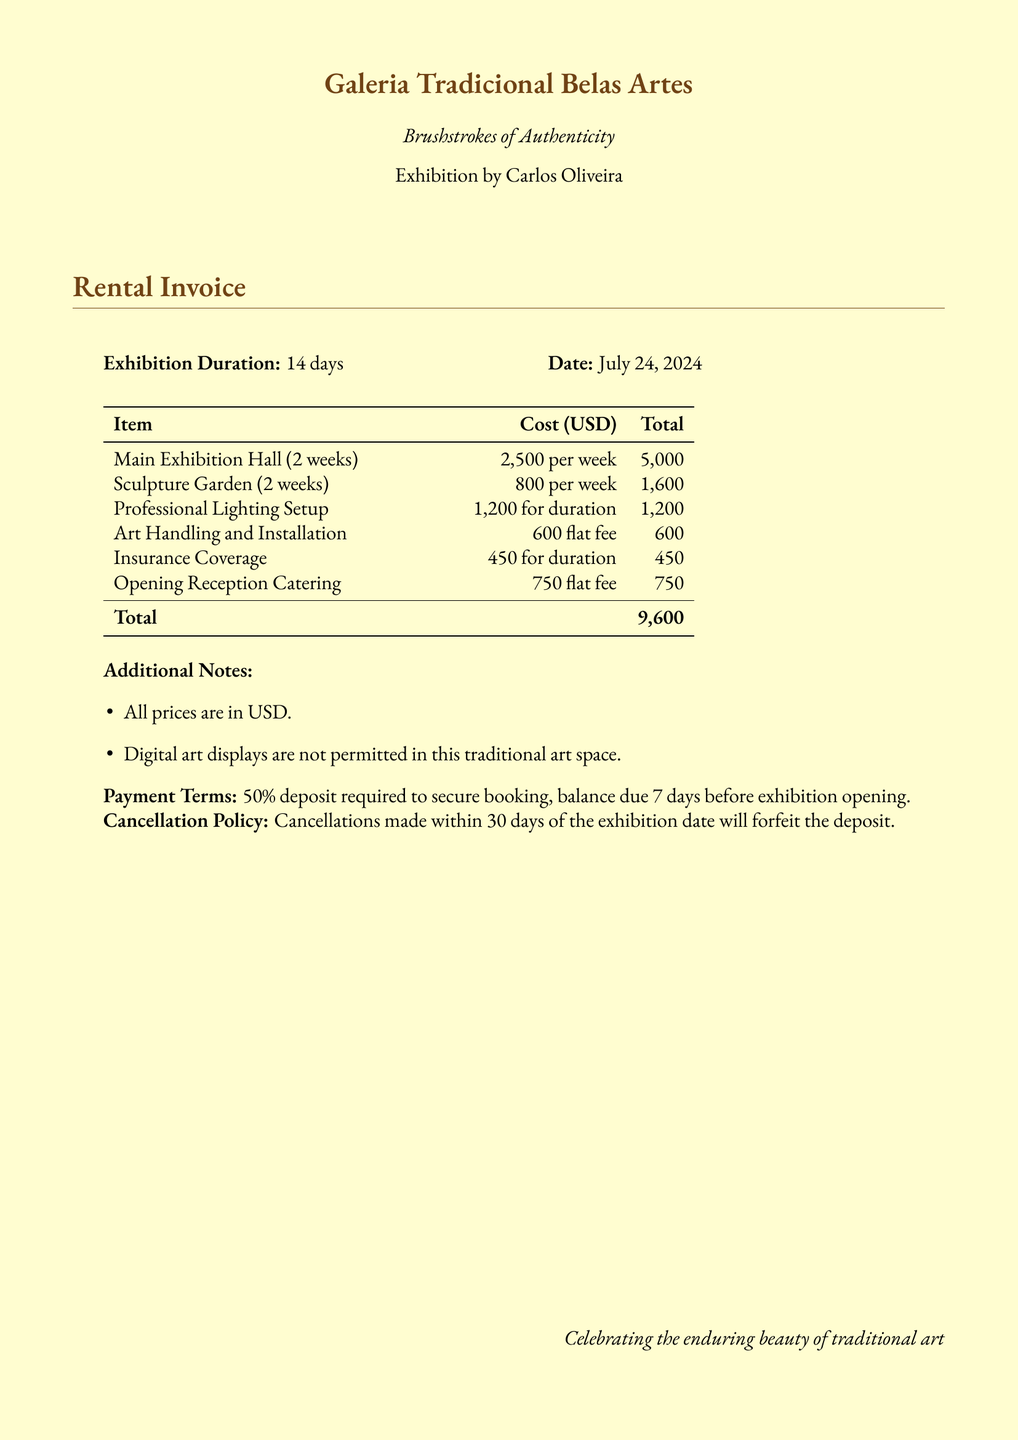What is the name of the exhibition? The exhibition is titled "Brushstrokes of Authenticity" by Carlos Oliveira.
Answer: Brushstrokes of Authenticity How long is the exhibition duration? The exhibition is set for a duration of 14 days.
Answer: 14 days What is the total cost of the gallery rental? The total cost is found at the bottom of the invoice, summing up all charges listed.
Answer: 9,600 How much is the insurance coverage? The insurance coverage cost is specified in the itemized list of costs.
Answer: 450 What is the deposit percentage required to secure booking? The payment terms specify the deposit percentage required for booking.
Answer: 50% What is included in the additional notes? The additional notes detail the price currency and restrictions on art displays.
Answer: Digital art displays are not permitted in this traditional art space What is the cancellation policy? The cancellation policy outlines the terms under which deposits are forfeited.
Answer: Cancellations made within 30 days of the exhibition date will forfeit the deposit How much is the cost for art handling and installation? The cost for art handling and installation is listed in the itemized costs.
Answer: 600 What is the cost for professional lighting setup? The professional lighting setup cost is provided in the invoice.
Answer: 1,200 